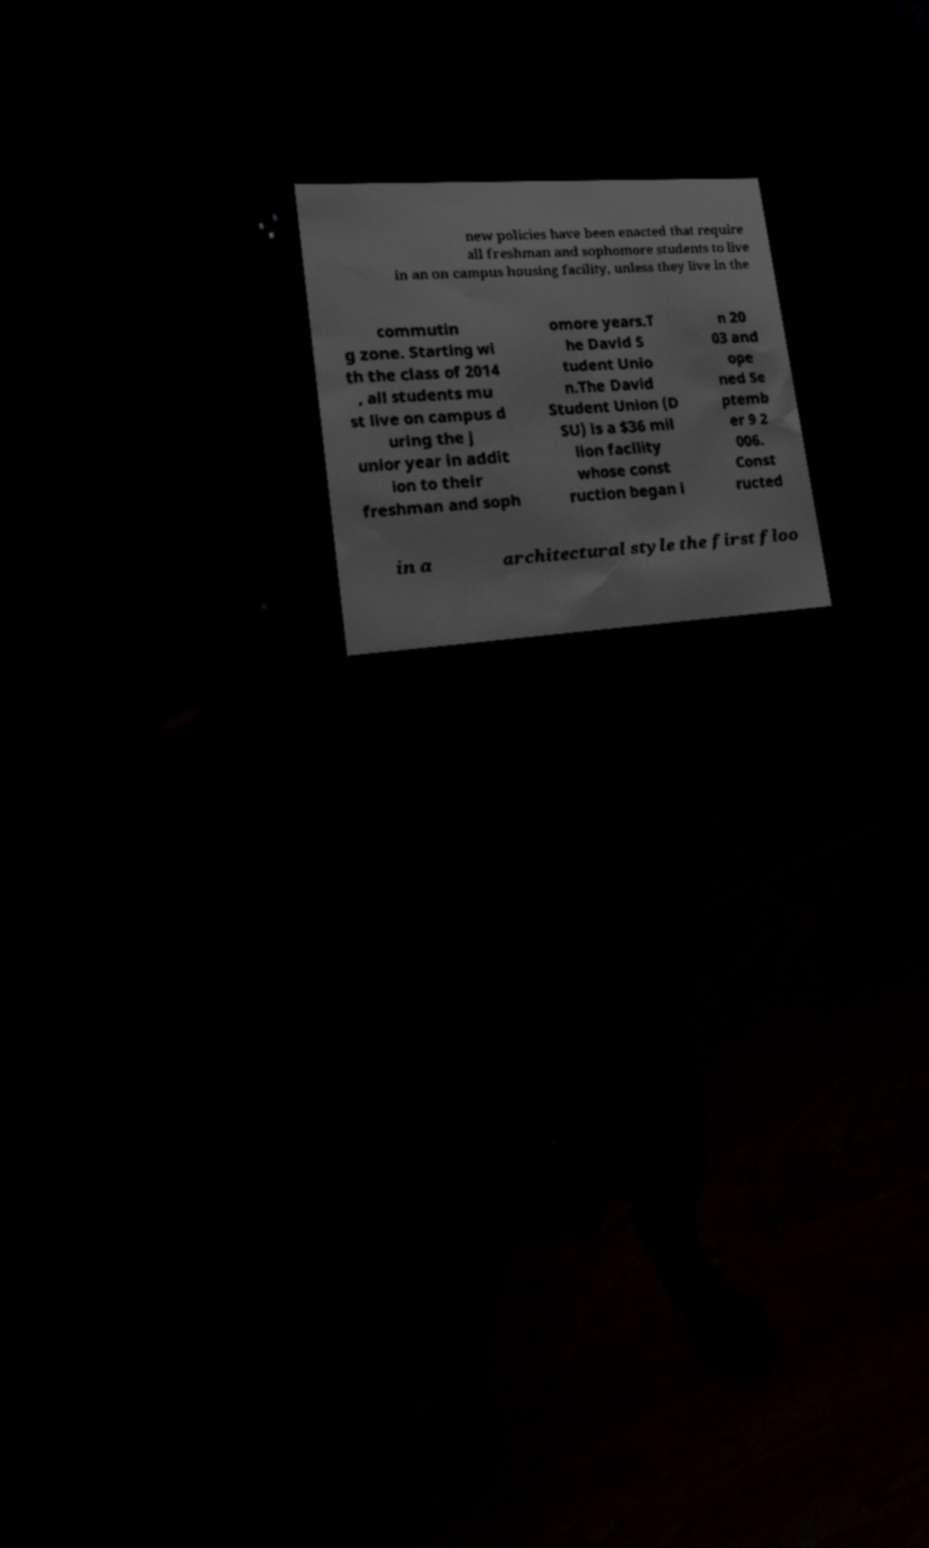Can you read and provide the text displayed in the image?This photo seems to have some interesting text. Can you extract and type it out for me? new policies have been enacted that require all freshman and sophomore students to live in an on campus housing facility, unless they live in the commutin g zone. Starting wi th the class of 2014 , all students mu st live on campus d uring the j unior year in addit ion to their freshman and soph omore years.T he David S tudent Unio n.The David Student Union (D SU) is a $36 mil lion facility whose const ruction began i n 20 03 and ope ned Se ptemb er 9 2 006. Const ructed in a architectural style the first floo 